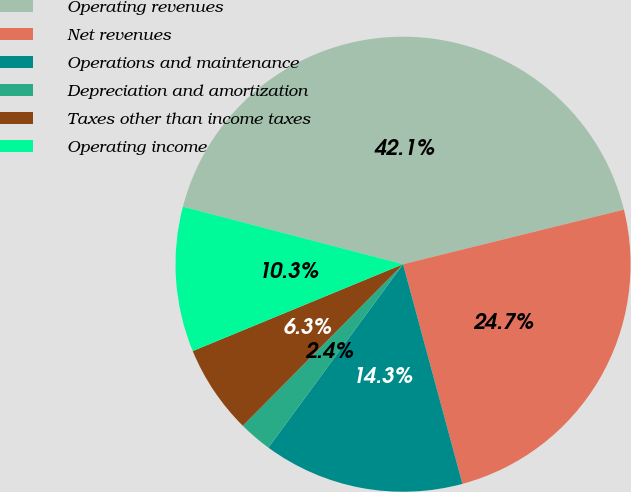<chart> <loc_0><loc_0><loc_500><loc_500><pie_chart><fcel>Operating revenues<fcel>Net revenues<fcel>Operations and maintenance<fcel>Depreciation and amortization<fcel>Taxes other than income taxes<fcel>Operating income<nl><fcel>42.07%<fcel>24.65%<fcel>14.28%<fcel>2.36%<fcel>6.33%<fcel>10.3%<nl></chart> 